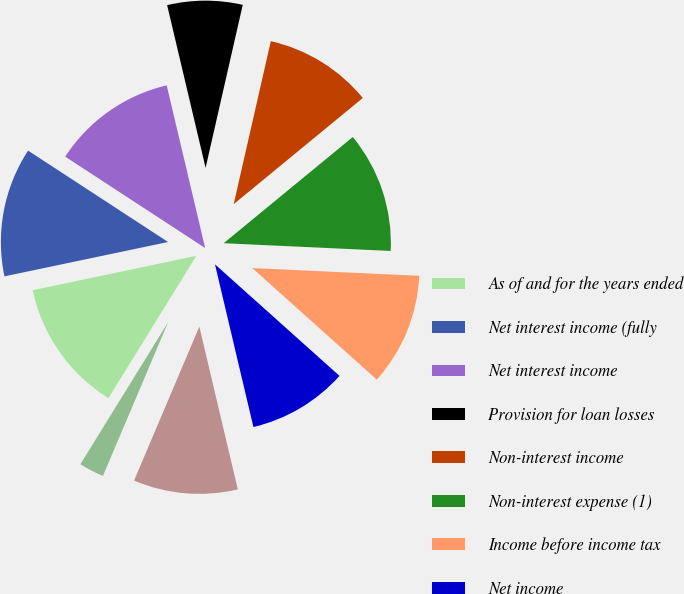Convert chart. <chart><loc_0><loc_0><loc_500><loc_500><pie_chart><fcel>As of and for the years ended<fcel>Net interest income (fully<fcel>Net interest income<fcel>Provision for loan losses<fcel>Non-interest income<fcel>Non-interest expense (1)<fcel>Income before income tax<fcel>Net income<fcel>Net income available to common<fcel>Net interest margin<nl><fcel>12.9%<fcel>12.5%<fcel>12.1%<fcel>7.26%<fcel>10.48%<fcel>11.69%<fcel>10.89%<fcel>9.68%<fcel>10.08%<fcel>2.42%<nl></chart> 